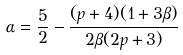<formula> <loc_0><loc_0><loc_500><loc_500>\alpha = \frac { 5 } { 2 } - \frac { ( p + 4 ) ( 1 + 3 \beta ) } { 2 \beta ( 2 p + 3 ) }</formula> 